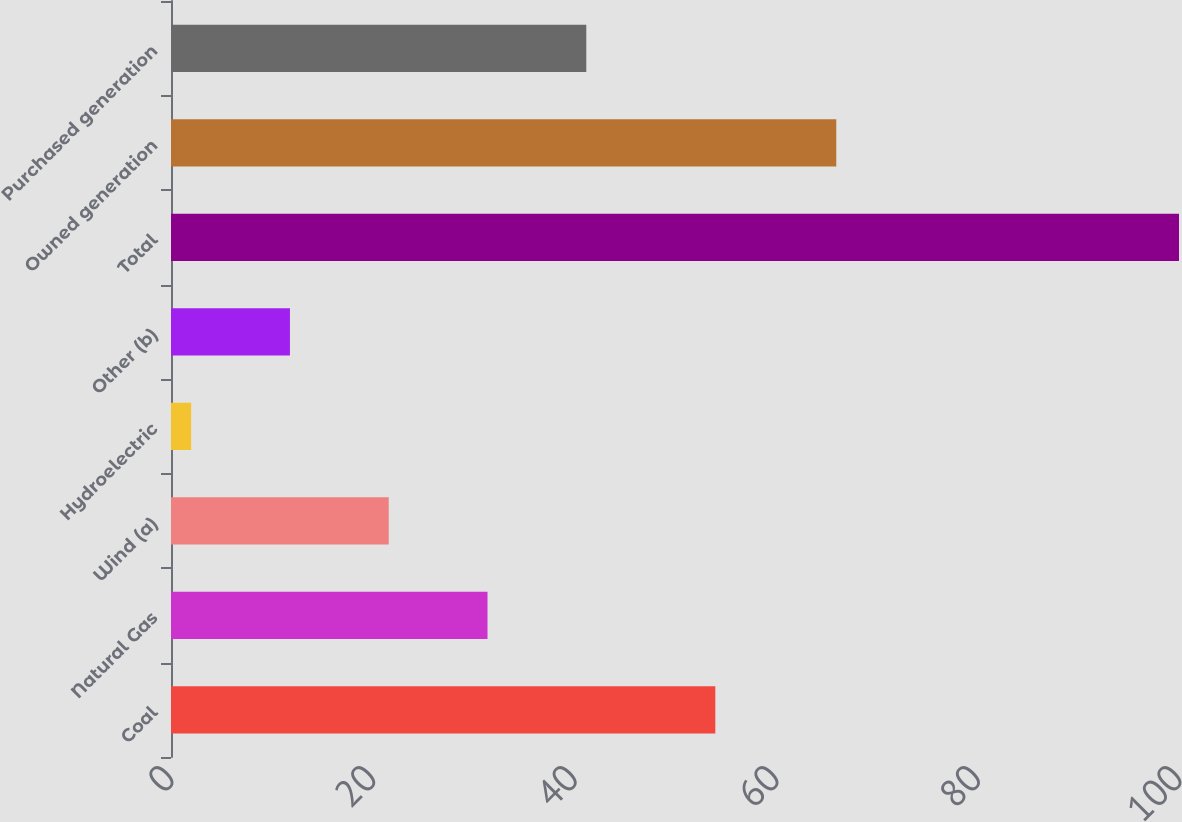Convert chart. <chart><loc_0><loc_0><loc_500><loc_500><bar_chart><fcel>Coal<fcel>Natural Gas<fcel>Wind (a)<fcel>Hydroelectric<fcel>Other (b)<fcel>Total<fcel>Owned generation<fcel>Purchased generation<nl><fcel>54<fcel>31.4<fcel>21.6<fcel>2<fcel>11.8<fcel>100<fcel>66<fcel>41.2<nl></chart> 